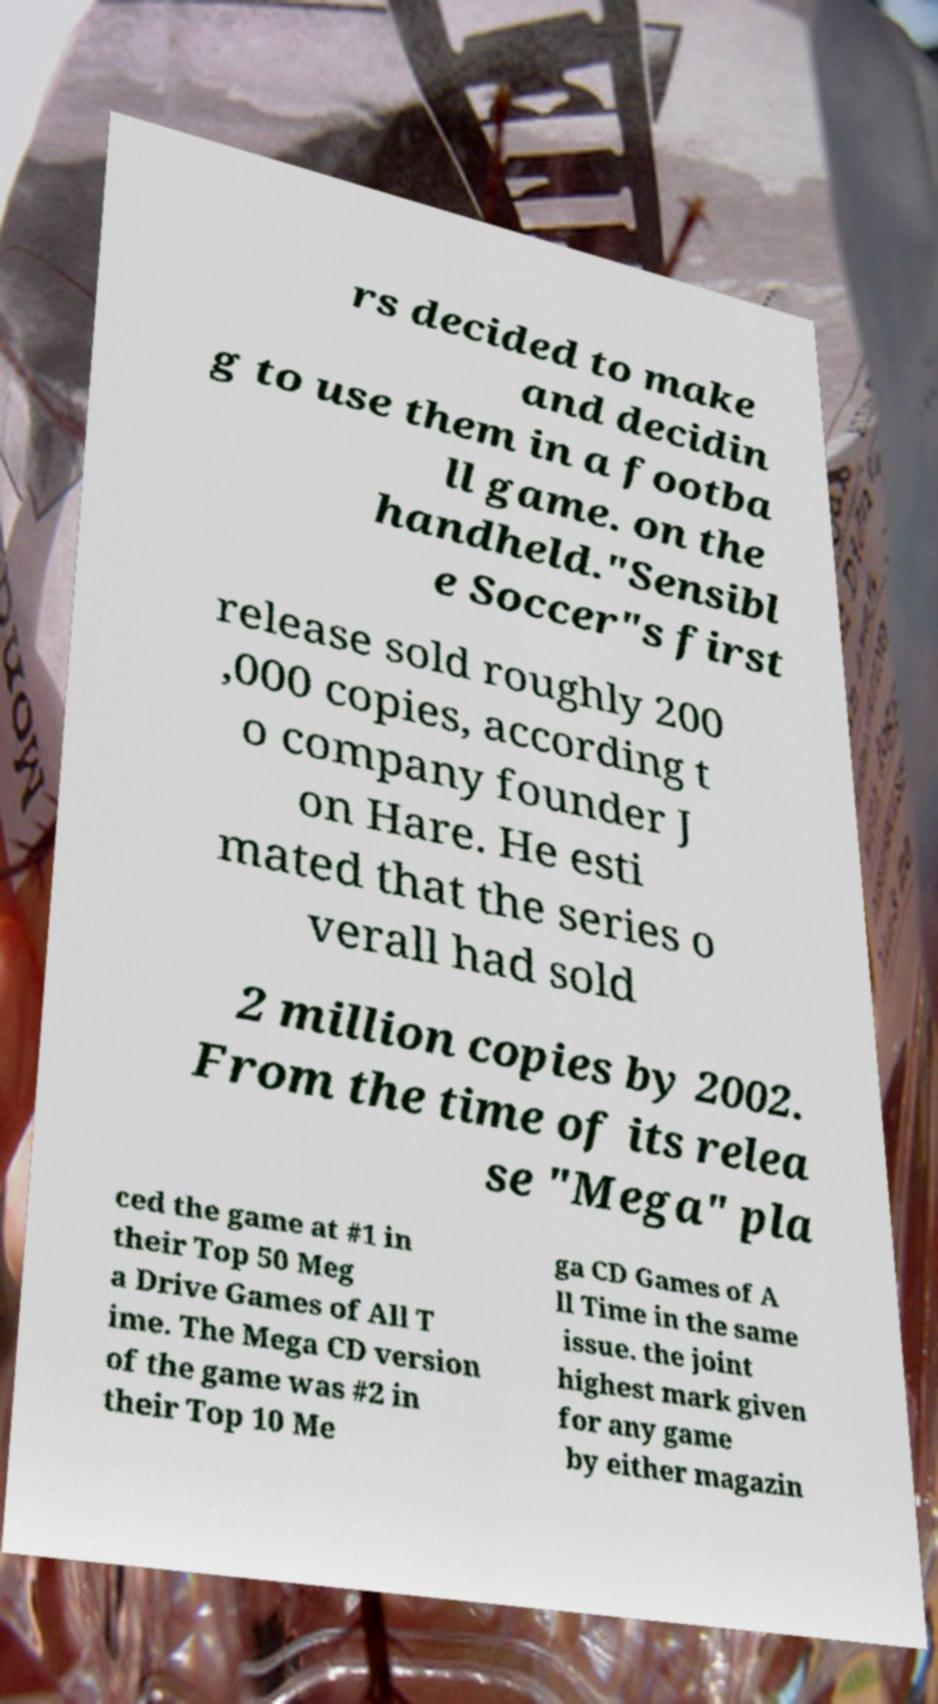Please read and relay the text visible in this image. What does it say? rs decided to make and decidin g to use them in a footba ll game. on the handheld."Sensibl e Soccer"s first release sold roughly 200 ,000 copies, according t o company founder J on Hare. He esti mated that the series o verall had sold 2 million copies by 2002. From the time of its relea se "Mega" pla ced the game at #1 in their Top 50 Meg a Drive Games of All T ime. The Mega CD version of the game was #2 in their Top 10 Me ga CD Games of A ll Time in the same issue. the joint highest mark given for any game by either magazin 